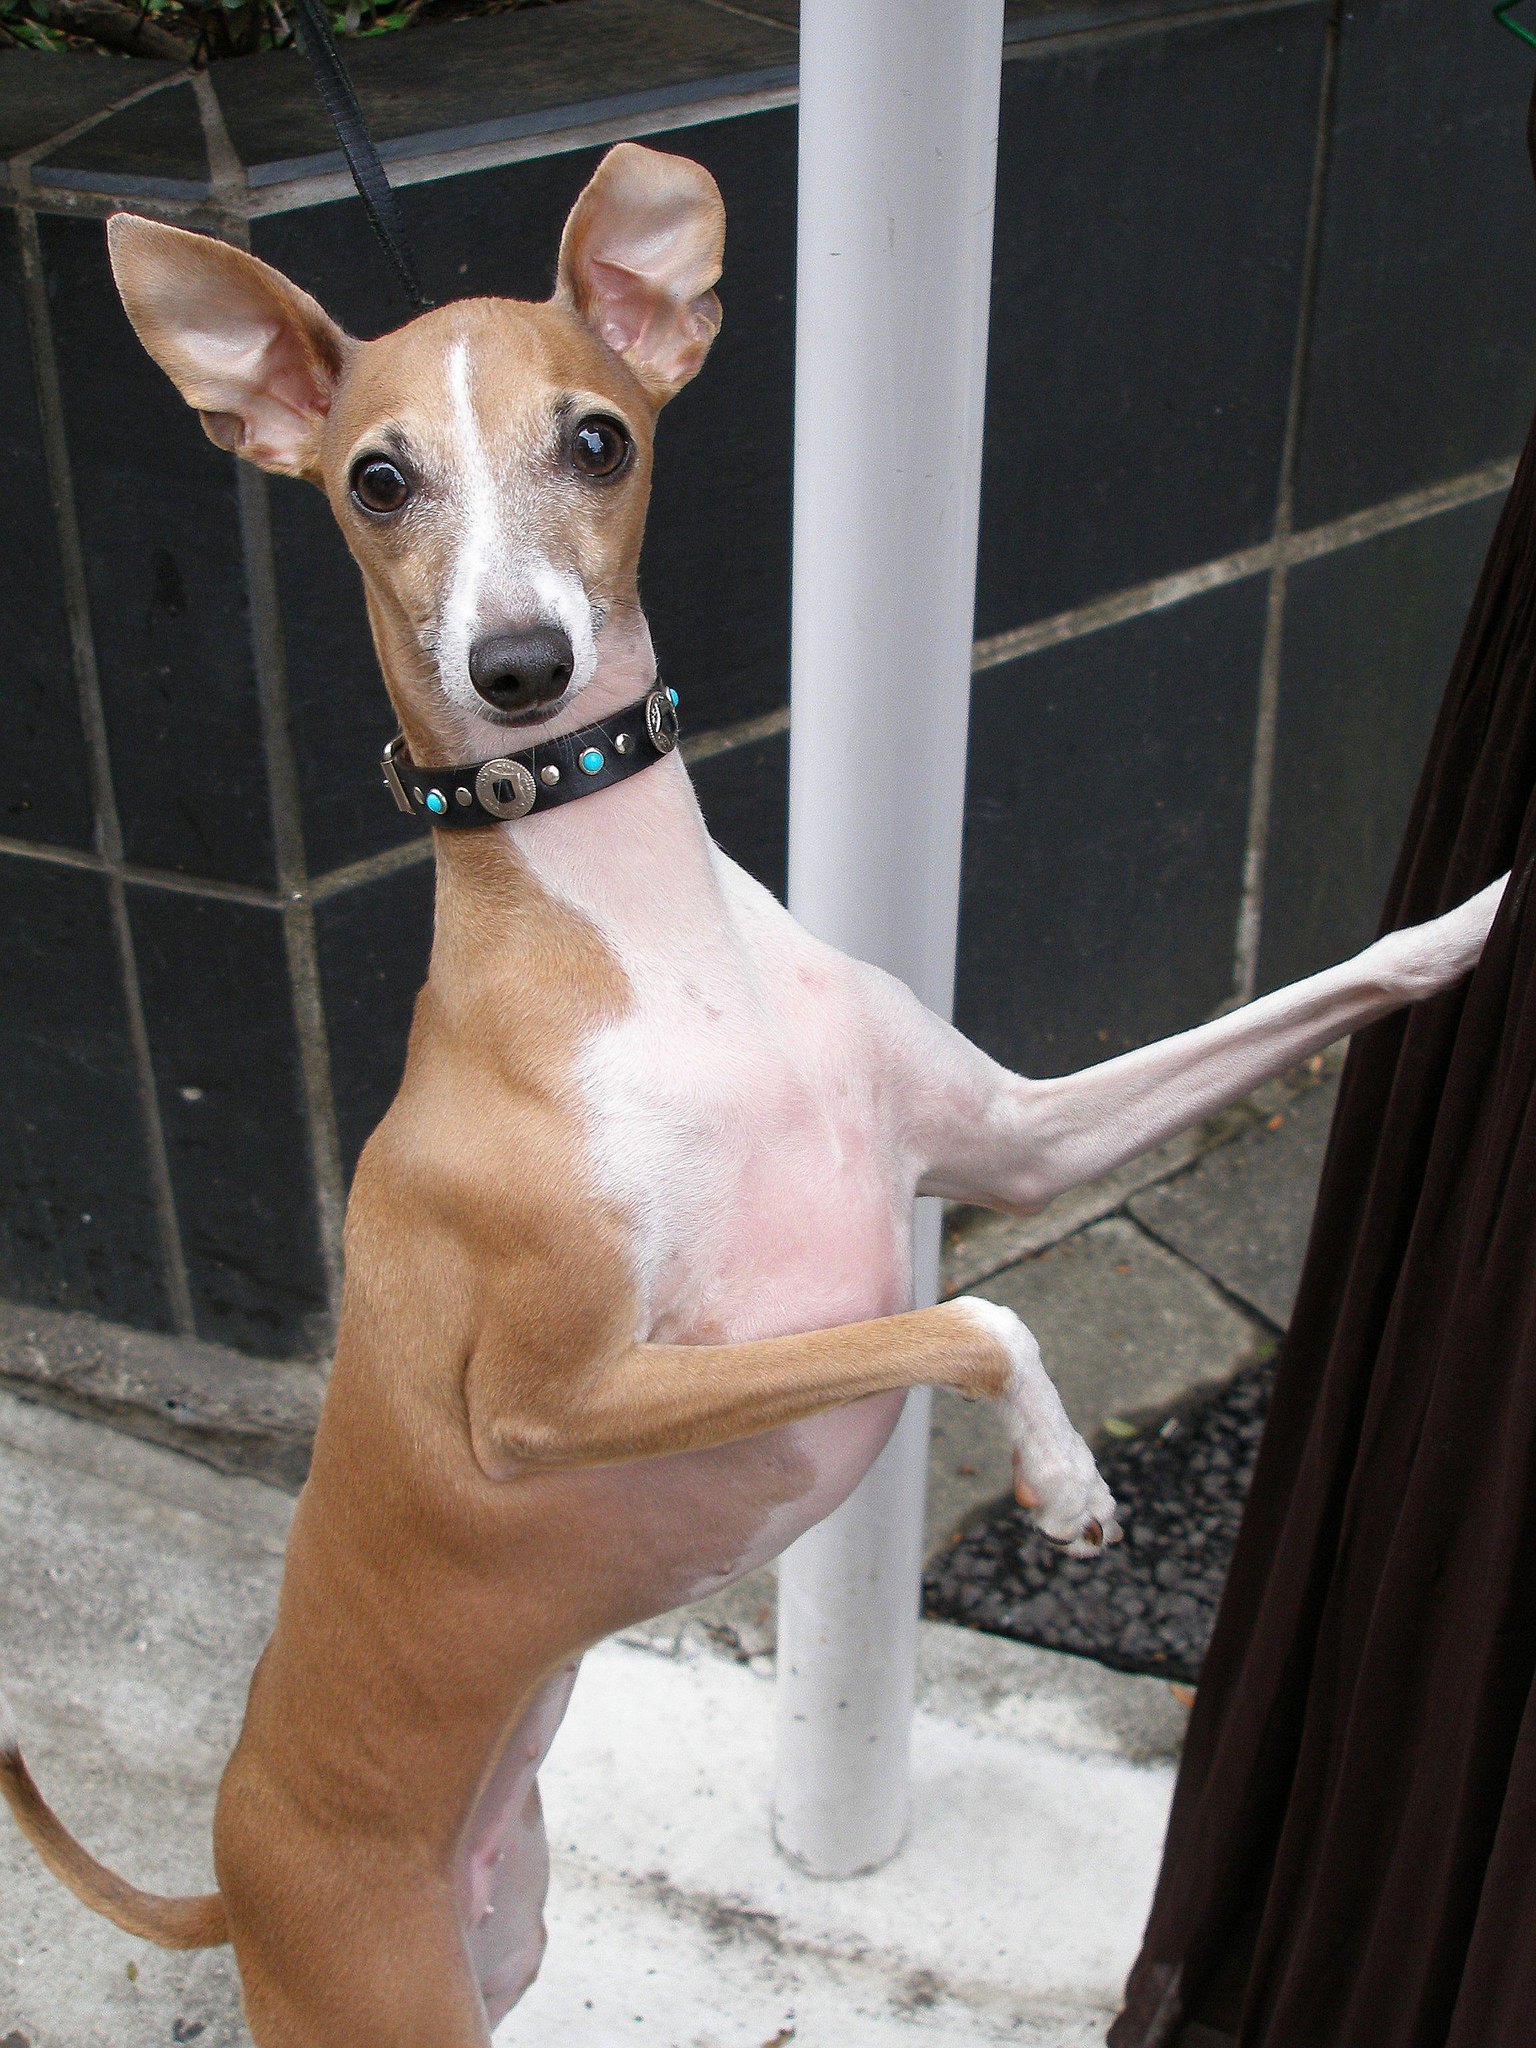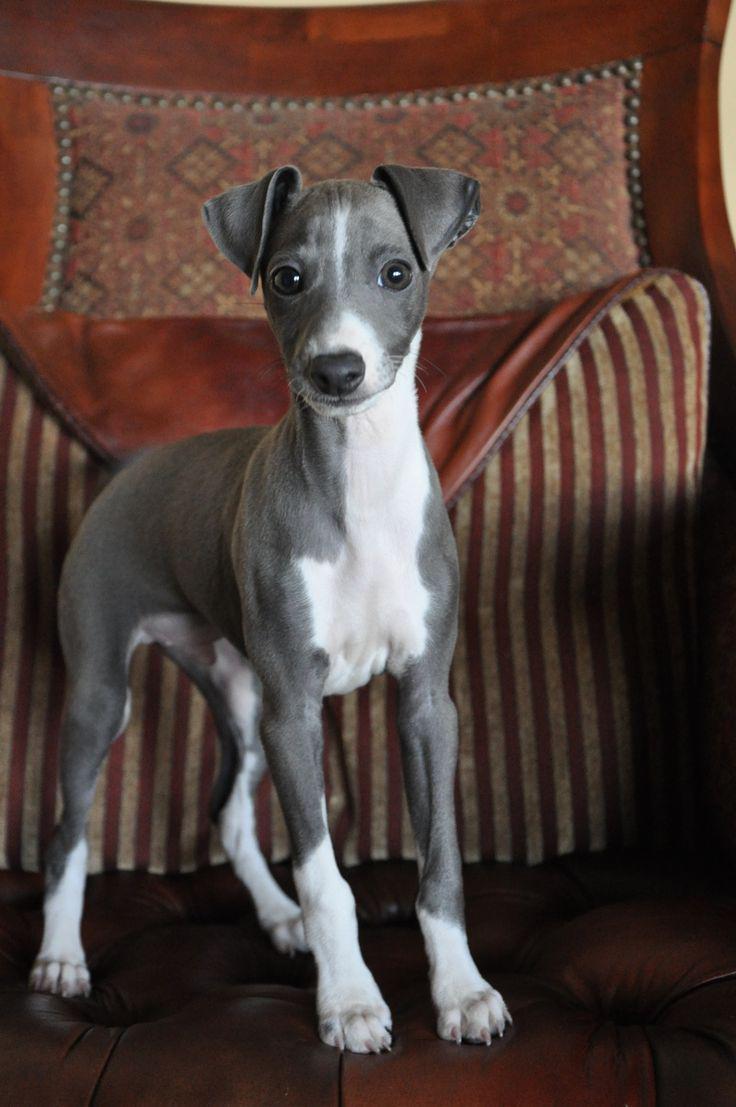The first image is the image on the left, the second image is the image on the right. Analyze the images presented: Is the assertion "An image contains a pair of similarly-posed dogs wearing similar items around their necks." valid? Answer yes or no. No. The first image is the image on the left, the second image is the image on the right. For the images shown, is this caption "In one image, a person is holding at least one little dog." true? Answer yes or no. No. The first image is the image on the left, the second image is the image on the right. Given the left and right images, does the statement "The right image contains exactly two dogs seated next to each other looking towards the right." hold true? Answer yes or no. No. The first image is the image on the left, the second image is the image on the right. Analyze the images presented: Is the assertion "In total, four dogs are shown." valid? Answer yes or no. No. 